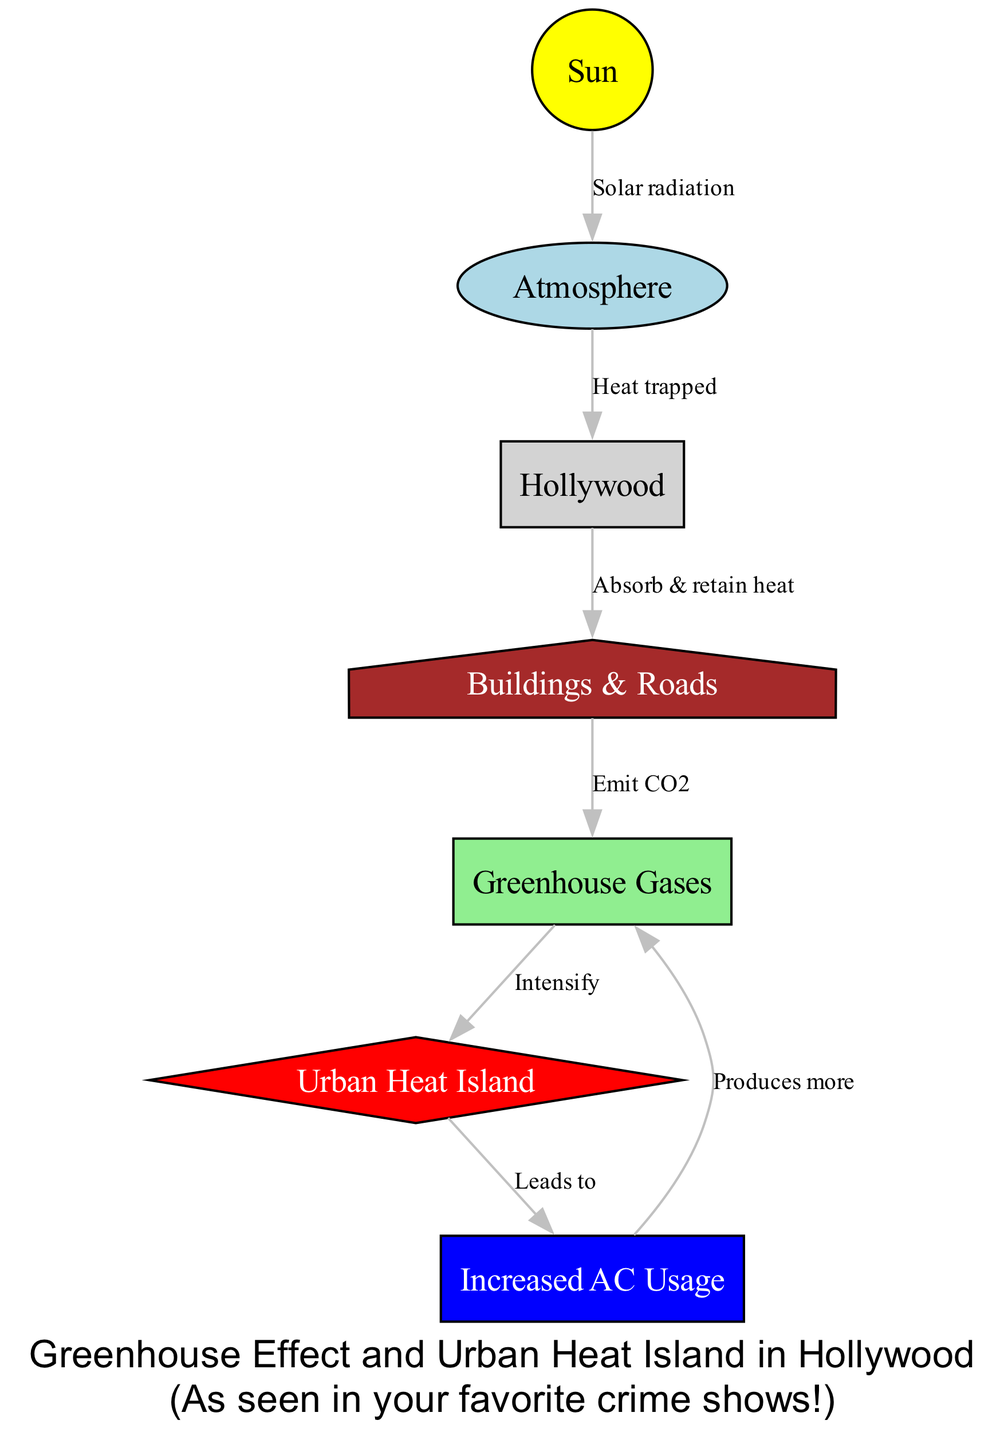What is the primary source of energy depicted in the diagram? The diagram identifies the "Sun" as the primary source of energy, indicated as the initial node from which solar radiation flows into the atmosphere.
Answer: Sun How many nodes are present in the diagram? By counting the distinct elements represented in the diagram, we identify a total of seven nodes which include the Sun, Atmosphere, Hollywood, Buildings & Roads, Greenhouse Gases, Urban Heat Island, and Increased AC Usage.
Answer: Seven What type of relationship exists between "Atmosphere" and "Hollywood"? The relationship labeled "Heat trapped" indicates that heat is retained by Hollywood as part of the greenhouse effect, showing the atmospheric impact on the urban area.
Answer: Heat trapped What do the "Buildings & Roads" do to heat according to the diagram? The diagram specifies that the "Buildings & Roads" absorb and retain heat, demonstrating their role in increasing local temperatures in the urban environment.
Answer: Absorb & retain heat What effect do greenhouse gases have on the urban heat island? The diagram illustrates that greenhouse gases "intensify" the urban heat island effect, suggesting a feedback loop that exacerbates heat concentration in urban areas.
Answer: Intensify What leads to increased AC usage in Hollywood? According to the diagram, the "Urban Heat Island" effect leads to increased air conditioning usage, which is a direct response to the higher temperatures experienced in the area.
Answer: Leads to How do increased AC usage affect greenhouse gases? The diagram shows that the increased usage of air conditioning produces more greenhouse gases, linking energy consumption in cooling systems to air pollution.
Answer: Produces more In which shape is the "Heatisland" represented in the diagram? The "Heatisland" is represented as a diamond shape in the diagram, distinguishing it from other elements with unique geometrical representation.
Answer: Diamond What do buildings emit that contributes to greenhouse gases? The diagram indicates that buildings and roads emit CO2, which contributes to the accumulation of greenhouse gases.
Answer: Emit CO2 